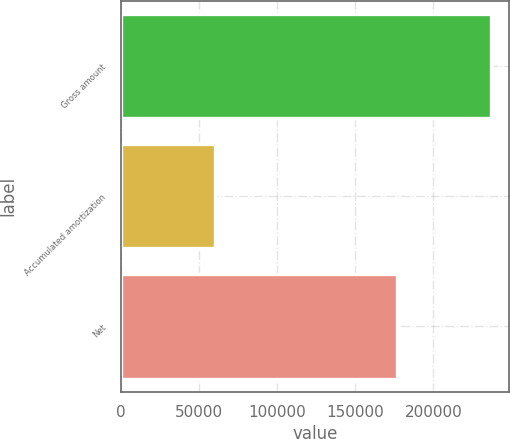Convert chart. <chart><loc_0><loc_0><loc_500><loc_500><bar_chart><fcel>Gross amount<fcel>Accumulated amortization<fcel>Net<nl><fcel>236594<fcel>60074<fcel>176520<nl></chart> 